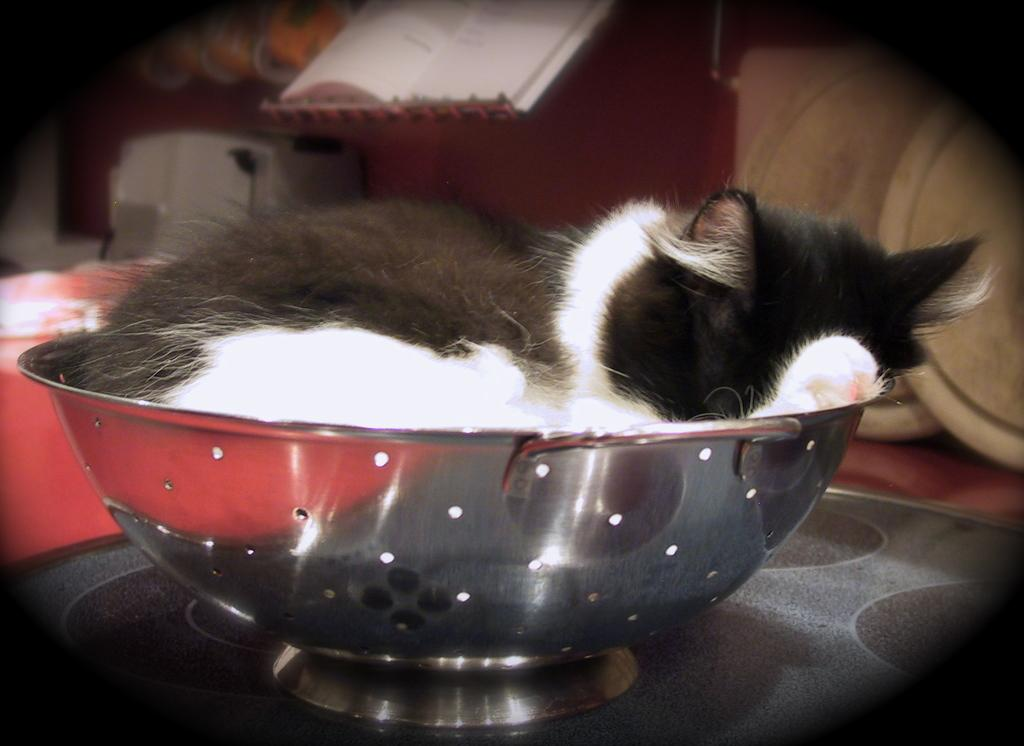What type of animal is in the vessel in the image? There is a black and white cat in a vessel in the image. What can be seen in the background of the image? There is a book in the background of the image. How would you describe the background of the image? The background is blurred. What type of jelly is the cat sitting on in the image? There is no jelly present in the image; the cat is in a vessel. How does the cat's sister interact with the cat in the image? There is no mention of a sister in the image, so it is not possible to answer that question. 